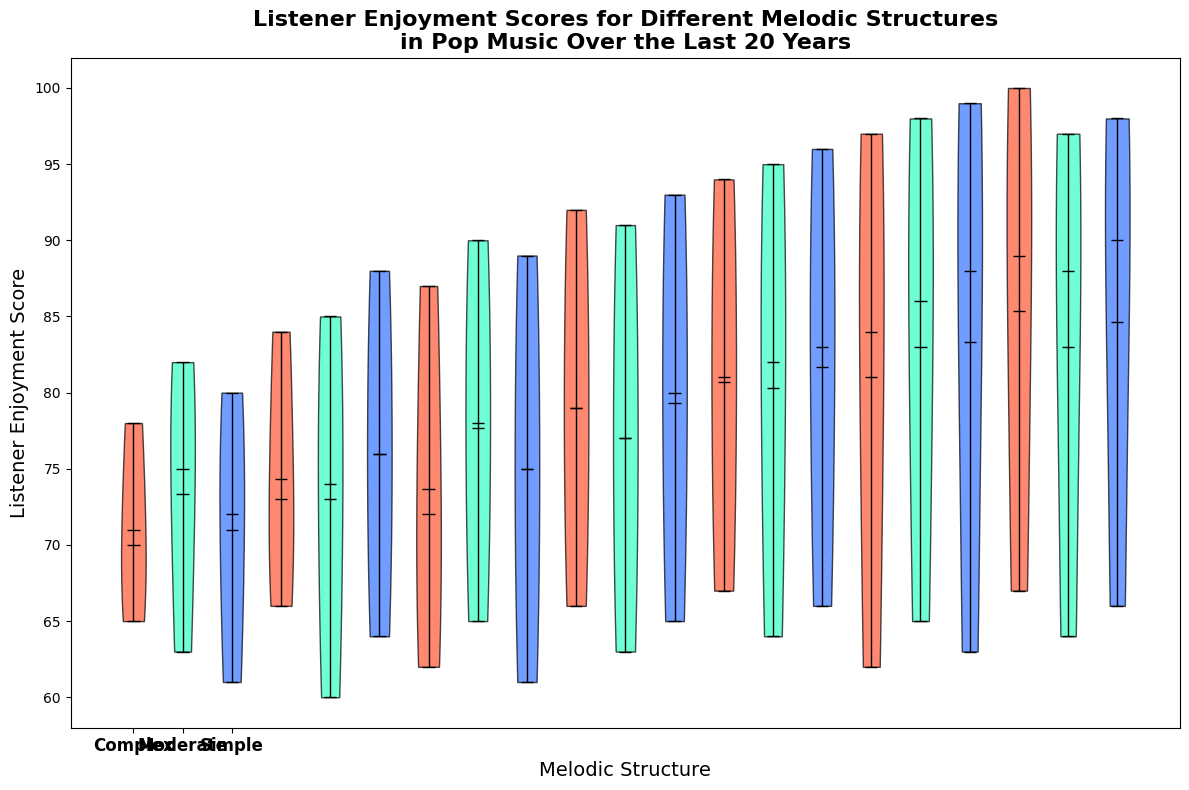Which melodic structure has the highest median Listener Enjoyment Score? The figure shows the violin plots with the median points marked. The structure with the highest median score is easily identified by its position on the vertical axis. Simple melodic structures appear to have the highest median score.
Answer: Simple What is the range of Listener Enjoyment Scores for Simple melodic structures? The plot shows the violins' vertical span which represents the range of the data. Look at the maximum and minimum points of the Simple violins to determine the range. The scores for Simple range from roughly 78 to 100.
Answer: 78-100 Which melodic structure has the lowest mean Listener Enjoyment Score? The mean value is indicated by the separate horizontal bar in each violin. Among the three structures, Complex has the lowest mean score based on its position.
Answer: Complex By how much does the highest Listener Enjoyment Score for Moderate melodic structures exceed the highest score for Complex structures? Estimate the highest points on the vertical axis for both Moderate and Complex violins. The highest score for Moderate appears close to 90, while for Complex it is about 67. The difference is approximately 90 - 67 = 23.
Answer: 23 Compare the median Listener Enjoyment Scores between Simple and Moderate melodic structures. Which is higher and by how much? Locate the median lines in the violins for both Simple and Moderate structures. The Simple median is close to 96, while the Moderate median is around 84. The difference is 96 - 84 = 12, making Simple higher by 12 points.
Answer: Simple, 12 What is the interquartile range (IQR) for Listener Enjoyment Scores in Complex melodic structures? The interquartile range can be observed as the thickness of the violin's middle section. For Complex structures, estimate the 25th and 75th percentile from the plot, around 61 and 66. The IQR is 66 - 61 = 5.
Answer: 5 